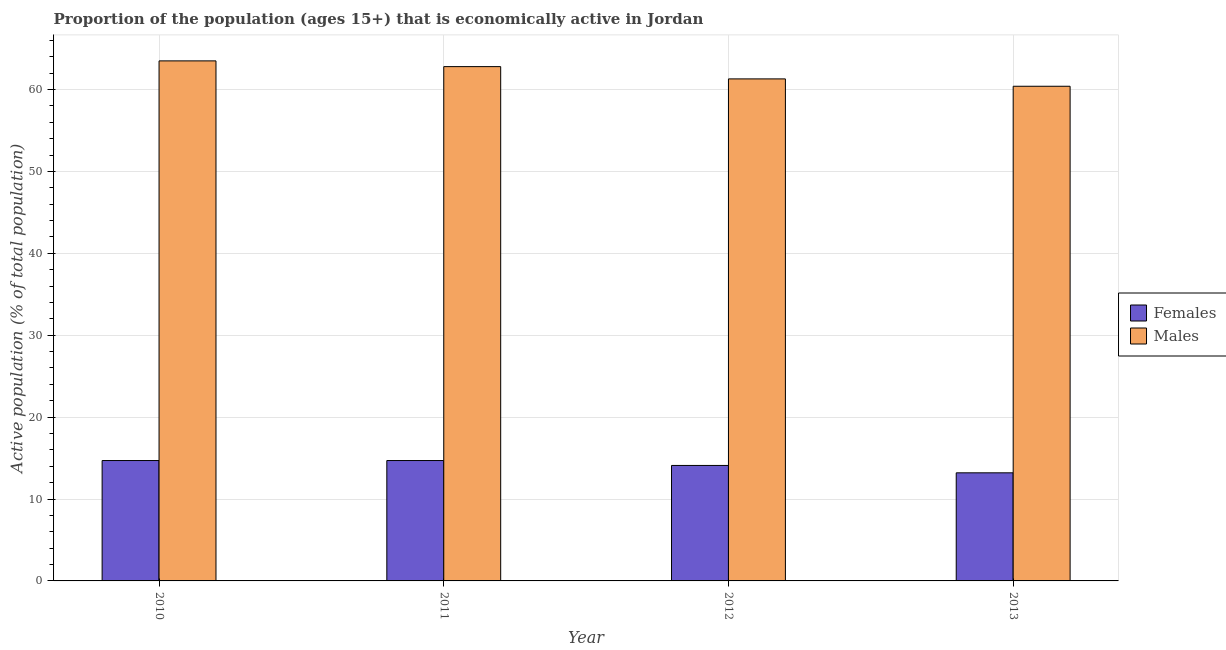How many groups of bars are there?
Provide a short and direct response. 4. Are the number of bars on each tick of the X-axis equal?
Keep it short and to the point. Yes. How many bars are there on the 3rd tick from the left?
Give a very brief answer. 2. In how many cases, is the number of bars for a given year not equal to the number of legend labels?
Provide a succinct answer. 0. What is the percentage of economically active male population in 2010?
Offer a terse response. 63.5. Across all years, what is the maximum percentage of economically active male population?
Offer a very short reply. 63.5. Across all years, what is the minimum percentage of economically active female population?
Your response must be concise. 13.2. In which year was the percentage of economically active male population maximum?
Your answer should be very brief. 2010. In which year was the percentage of economically active female population minimum?
Offer a very short reply. 2013. What is the total percentage of economically active male population in the graph?
Make the answer very short. 248. What is the difference between the percentage of economically active female population in 2010 and that in 2012?
Make the answer very short. 0.6. What is the difference between the percentage of economically active male population in 2013 and the percentage of economically active female population in 2010?
Keep it short and to the point. -3.1. What is the average percentage of economically active male population per year?
Your response must be concise. 62. In the year 2011, what is the difference between the percentage of economically active female population and percentage of economically active male population?
Give a very brief answer. 0. What is the ratio of the percentage of economically active male population in 2010 to that in 2011?
Provide a short and direct response. 1.01. Is the difference between the percentage of economically active female population in 2010 and 2011 greater than the difference between the percentage of economically active male population in 2010 and 2011?
Your answer should be compact. No. What is the difference between the highest and the second highest percentage of economically active male population?
Keep it short and to the point. 0.7. What is the difference between the highest and the lowest percentage of economically active male population?
Give a very brief answer. 3.1. What does the 1st bar from the left in 2013 represents?
Ensure brevity in your answer.  Females. What does the 2nd bar from the right in 2011 represents?
Provide a succinct answer. Females. What is the difference between two consecutive major ticks on the Y-axis?
Your response must be concise. 10. Are the values on the major ticks of Y-axis written in scientific E-notation?
Offer a very short reply. No. Does the graph contain any zero values?
Your answer should be compact. No. Does the graph contain grids?
Ensure brevity in your answer.  Yes. How are the legend labels stacked?
Offer a very short reply. Vertical. What is the title of the graph?
Offer a very short reply. Proportion of the population (ages 15+) that is economically active in Jordan. Does "Malaria" appear as one of the legend labels in the graph?
Your response must be concise. No. What is the label or title of the X-axis?
Your response must be concise. Year. What is the label or title of the Y-axis?
Give a very brief answer. Active population (% of total population). What is the Active population (% of total population) in Females in 2010?
Provide a short and direct response. 14.7. What is the Active population (% of total population) in Males in 2010?
Ensure brevity in your answer.  63.5. What is the Active population (% of total population) in Females in 2011?
Your answer should be compact. 14.7. What is the Active population (% of total population) in Males in 2011?
Keep it short and to the point. 62.8. What is the Active population (% of total population) of Females in 2012?
Ensure brevity in your answer.  14.1. What is the Active population (% of total population) in Males in 2012?
Offer a terse response. 61.3. What is the Active population (% of total population) of Females in 2013?
Your answer should be compact. 13.2. What is the Active population (% of total population) of Males in 2013?
Make the answer very short. 60.4. Across all years, what is the maximum Active population (% of total population) of Females?
Your answer should be very brief. 14.7. Across all years, what is the maximum Active population (% of total population) of Males?
Offer a very short reply. 63.5. Across all years, what is the minimum Active population (% of total population) of Females?
Your answer should be very brief. 13.2. Across all years, what is the minimum Active population (% of total population) of Males?
Your answer should be compact. 60.4. What is the total Active population (% of total population) in Females in the graph?
Provide a short and direct response. 56.7. What is the total Active population (% of total population) of Males in the graph?
Your response must be concise. 248. What is the difference between the Active population (% of total population) of Females in 2010 and that in 2011?
Offer a terse response. 0. What is the difference between the Active population (% of total population) of Males in 2010 and that in 2012?
Keep it short and to the point. 2.2. What is the difference between the Active population (% of total population) of Males in 2011 and that in 2013?
Provide a short and direct response. 2.4. What is the difference between the Active population (% of total population) of Males in 2012 and that in 2013?
Your response must be concise. 0.9. What is the difference between the Active population (% of total population) in Females in 2010 and the Active population (% of total population) in Males in 2011?
Make the answer very short. -48.1. What is the difference between the Active population (% of total population) in Females in 2010 and the Active population (% of total population) in Males in 2012?
Your response must be concise. -46.6. What is the difference between the Active population (% of total population) of Females in 2010 and the Active population (% of total population) of Males in 2013?
Provide a succinct answer. -45.7. What is the difference between the Active population (% of total population) of Females in 2011 and the Active population (% of total population) of Males in 2012?
Provide a short and direct response. -46.6. What is the difference between the Active population (% of total population) of Females in 2011 and the Active population (% of total population) of Males in 2013?
Provide a short and direct response. -45.7. What is the difference between the Active population (% of total population) of Females in 2012 and the Active population (% of total population) of Males in 2013?
Your response must be concise. -46.3. What is the average Active population (% of total population) of Females per year?
Provide a succinct answer. 14.18. What is the average Active population (% of total population) of Males per year?
Your response must be concise. 62. In the year 2010, what is the difference between the Active population (% of total population) of Females and Active population (% of total population) of Males?
Offer a very short reply. -48.8. In the year 2011, what is the difference between the Active population (% of total population) in Females and Active population (% of total population) in Males?
Make the answer very short. -48.1. In the year 2012, what is the difference between the Active population (% of total population) of Females and Active population (% of total population) of Males?
Provide a succinct answer. -47.2. In the year 2013, what is the difference between the Active population (% of total population) of Females and Active population (% of total population) of Males?
Give a very brief answer. -47.2. What is the ratio of the Active population (% of total population) of Males in 2010 to that in 2011?
Ensure brevity in your answer.  1.01. What is the ratio of the Active population (% of total population) in Females in 2010 to that in 2012?
Your response must be concise. 1.04. What is the ratio of the Active population (% of total population) in Males in 2010 to that in 2012?
Offer a terse response. 1.04. What is the ratio of the Active population (% of total population) in Females in 2010 to that in 2013?
Give a very brief answer. 1.11. What is the ratio of the Active population (% of total population) of Males in 2010 to that in 2013?
Keep it short and to the point. 1.05. What is the ratio of the Active population (% of total population) of Females in 2011 to that in 2012?
Your answer should be very brief. 1.04. What is the ratio of the Active population (% of total population) of Males in 2011 to that in 2012?
Ensure brevity in your answer.  1.02. What is the ratio of the Active population (% of total population) in Females in 2011 to that in 2013?
Give a very brief answer. 1.11. What is the ratio of the Active population (% of total population) in Males in 2011 to that in 2013?
Offer a very short reply. 1.04. What is the ratio of the Active population (% of total population) in Females in 2012 to that in 2013?
Provide a succinct answer. 1.07. What is the ratio of the Active population (% of total population) of Males in 2012 to that in 2013?
Keep it short and to the point. 1.01. What is the difference between the highest and the second highest Active population (% of total population) in Females?
Provide a short and direct response. 0. What is the difference between the highest and the lowest Active population (% of total population) of Females?
Your response must be concise. 1.5. What is the difference between the highest and the lowest Active population (% of total population) of Males?
Give a very brief answer. 3.1. 